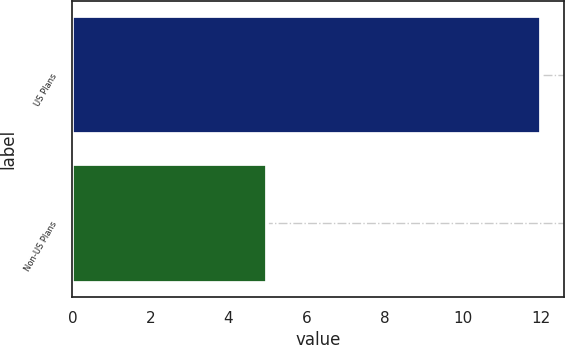Convert chart. <chart><loc_0><loc_0><loc_500><loc_500><bar_chart><fcel>US Plans<fcel>Non-US Plans<nl><fcel>12<fcel>5<nl></chart> 